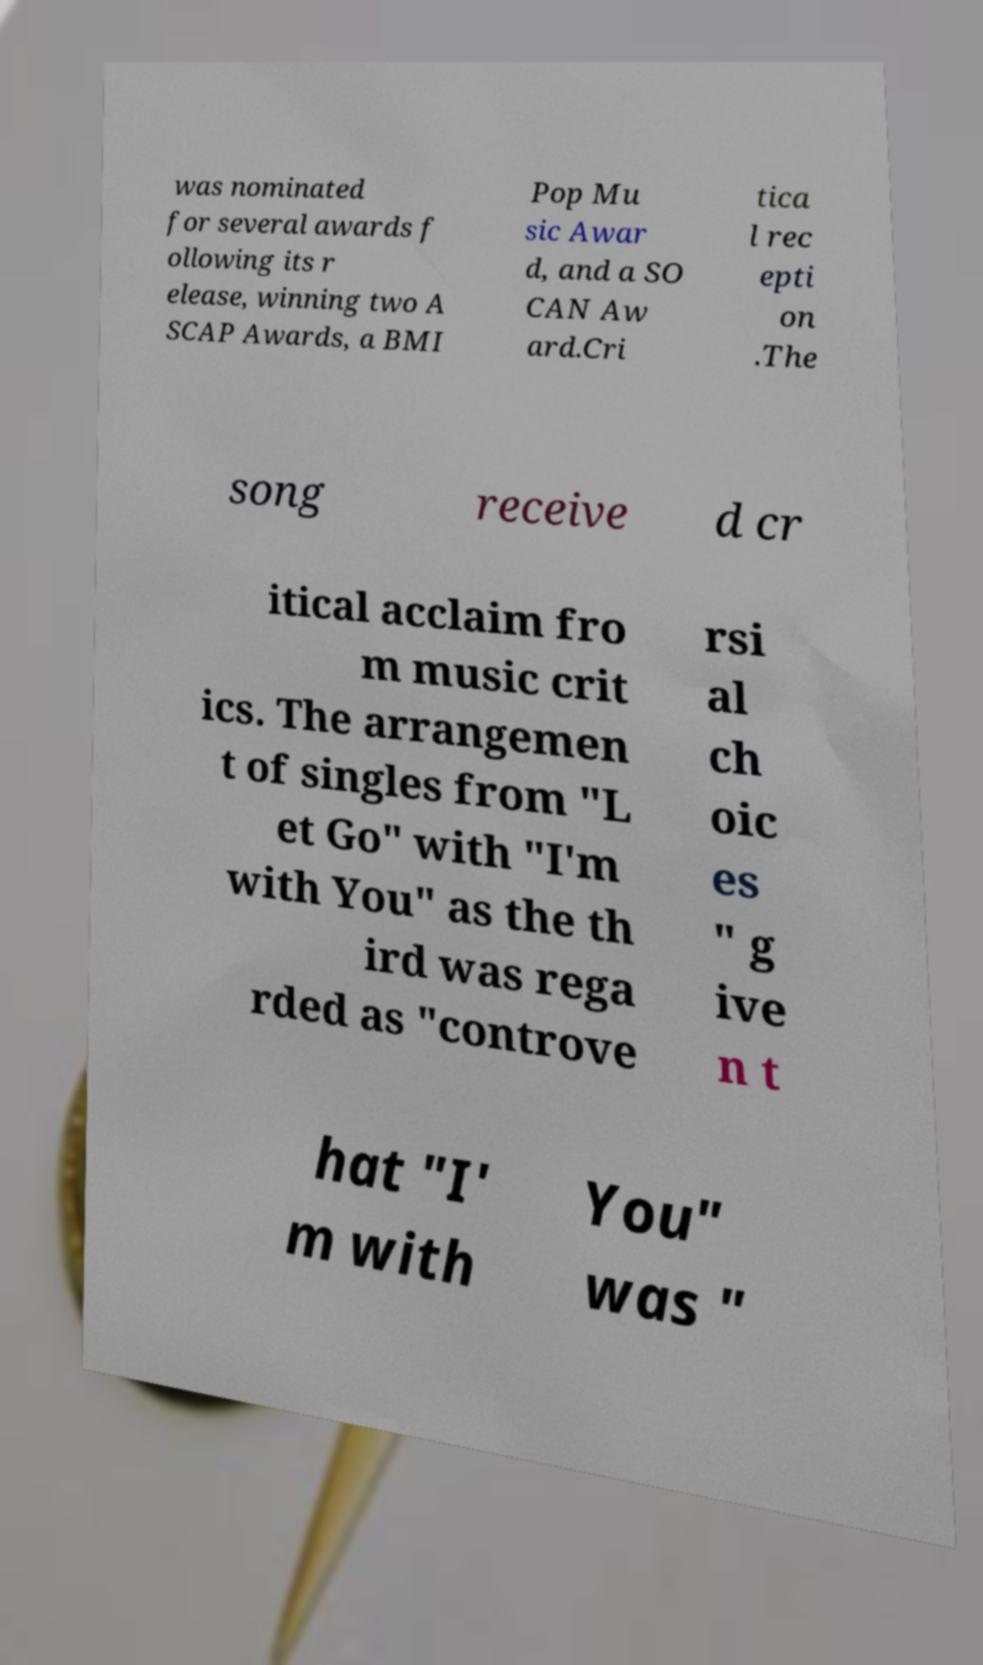Could you extract and type out the text from this image? was nominated for several awards f ollowing its r elease, winning two A SCAP Awards, a BMI Pop Mu sic Awar d, and a SO CAN Aw ard.Cri tica l rec epti on .The song receive d cr itical acclaim fro m music crit ics. The arrangemen t of singles from "L et Go" with "I'm with You" as the th ird was rega rded as "controve rsi al ch oic es " g ive n t hat "I' m with You" was " 